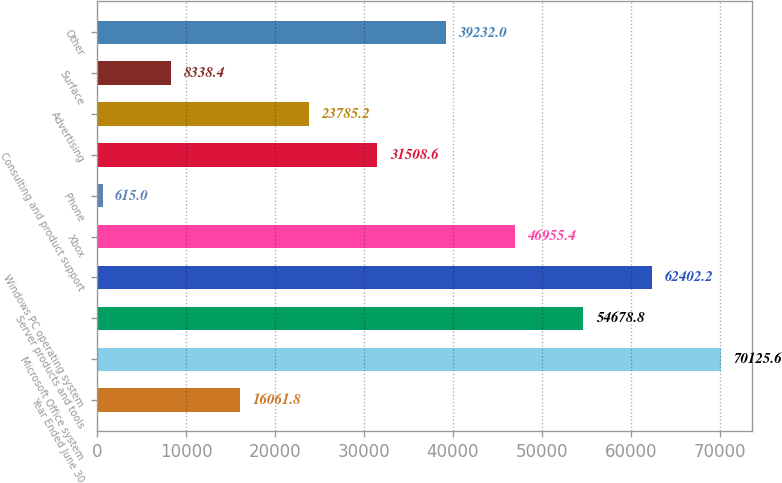Convert chart to OTSL. <chart><loc_0><loc_0><loc_500><loc_500><bar_chart><fcel>Year Ended June 30<fcel>Microsoft Office system<fcel>Server products and tools<fcel>Windows PC operating system<fcel>Xbox<fcel>Phone<fcel>Consulting and product support<fcel>Advertising<fcel>Surface<fcel>Other<nl><fcel>16061.8<fcel>70125.6<fcel>54678.8<fcel>62402.2<fcel>46955.4<fcel>615<fcel>31508.6<fcel>23785.2<fcel>8338.4<fcel>39232<nl></chart> 